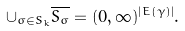Convert formula to latex. <formula><loc_0><loc_0><loc_500><loc_500>\cup _ { \sigma \in S _ { k } } \overline { S _ { \sigma } } = ( 0 , \infty ) ^ { | E ( \gamma ) | } .</formula> 